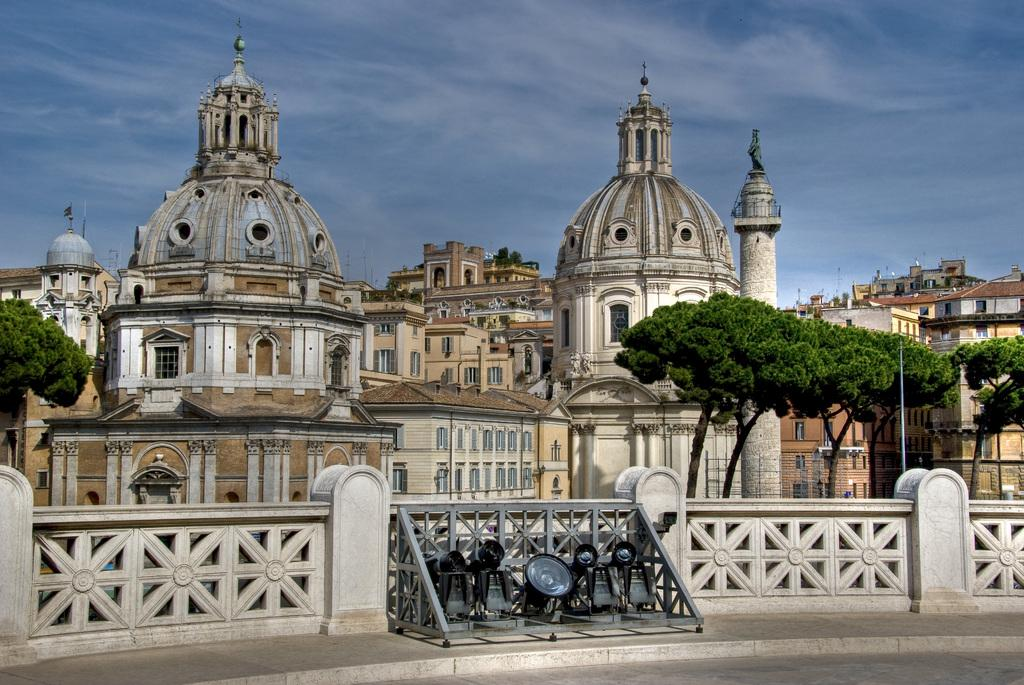What type of structures can be seen in the image? There are buildings in the image. What colors are the buildings? The buildings are in white, brown, and cream colors. What other natural elements can be seen in the image? There are trees in the image. What is the color of the trees? The trees are green. Are there any artificial light sources visible in the image? Yes, there are lights visible in the image. What can be seen in the background of the image? The sky is visible in the background of the image, and it is blue. What type of zinc is present in the image? There is no zinc present in the image. Can you tell me how many notebooks are visible in the image? There are no notebooks visible in the image. 